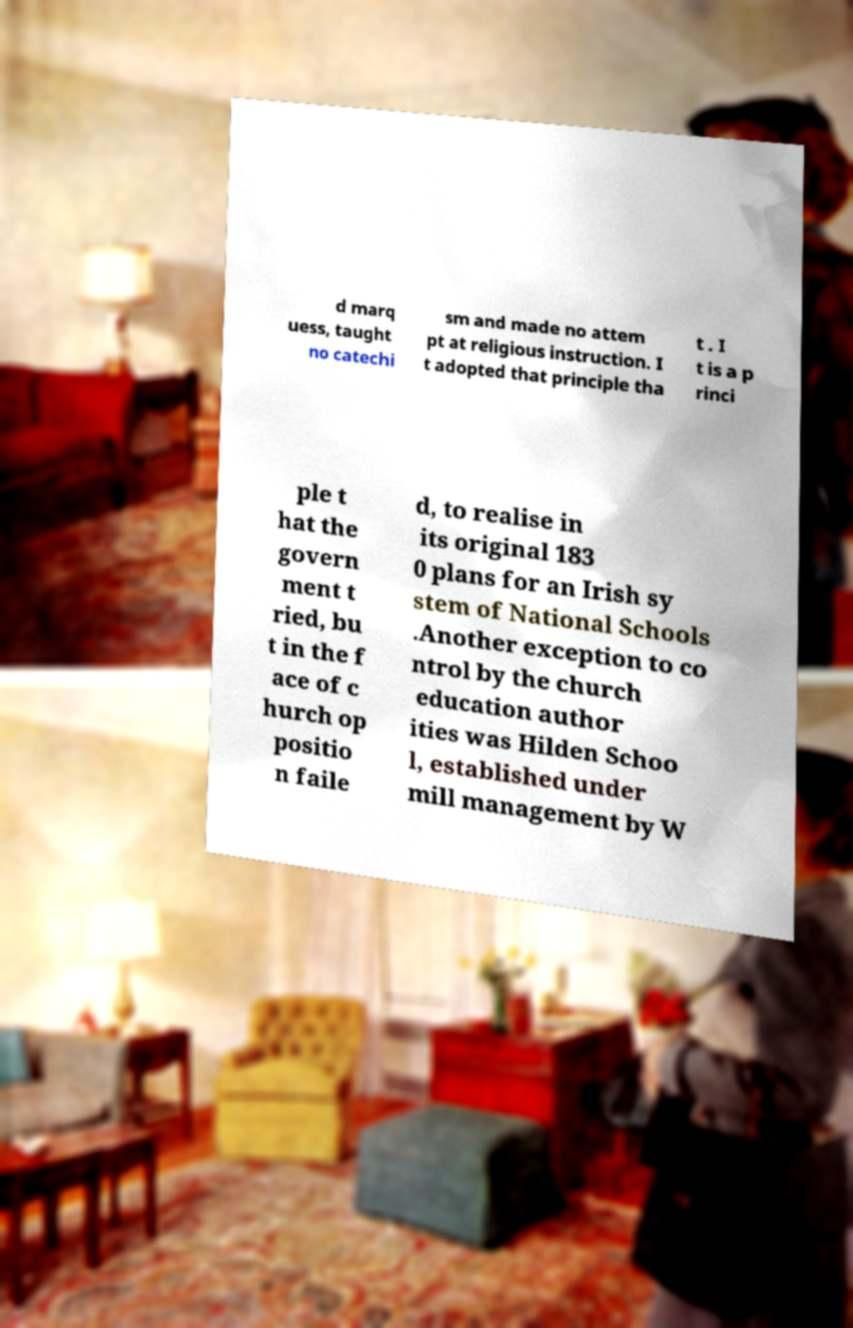Can you accurately transcribe the text from the provided image for me? d marq uess, taught no catechi sm and made no attem pt at religious instruction. I t adopted that principle tha t . I t is a p rinci ple t hat the govern ment t ried, bu t in the f ace of c hurch op positio n faile d, to realise in its original 183 0 plans for an Irish sy stem of National Schools .Another exception to co ntrol by the church education author ities was Hilden Schoo l, established under mill management by W 